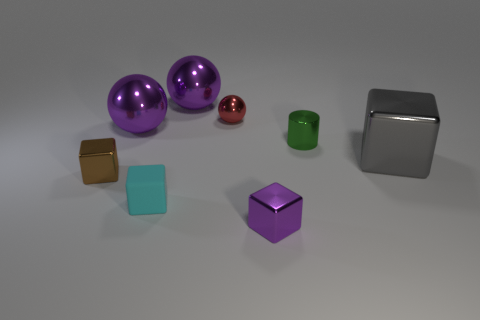Is there anything else that is the same material as the tiny cyan block?
Offer a very short reply. No. Are the brown block and the tiny cyan cube made of the same material?
Make the answer very short. No. Is the tiny rubber object the same shape as the small brown shiny object?
Provide a succinct answer. Yes. The matte object that is the same size as the purple shiny cube is what color?
Provide a short and direct response. Cyan. Are there any spheres?
Your answer should be compact. Yes. Are the purple object in front of the gray block and the cyan thing made of the same material?
Your answer should be compact. No. How many gray metallic balls have the same size as the red thing?
Provide a short and direct response. 0. Are there the same number of tiny red metallic objects that are in front of the small red shiny object and big green metal blocks?
Provide a succinct answer. Yes. What number of shiny things are both in front of the big metallic cube and on the right side of the small cyan object?
Give a very brief answer. 1. What is the size of the gray thing that is the same material as the purple block?
Provide a succinct answer. Large. 